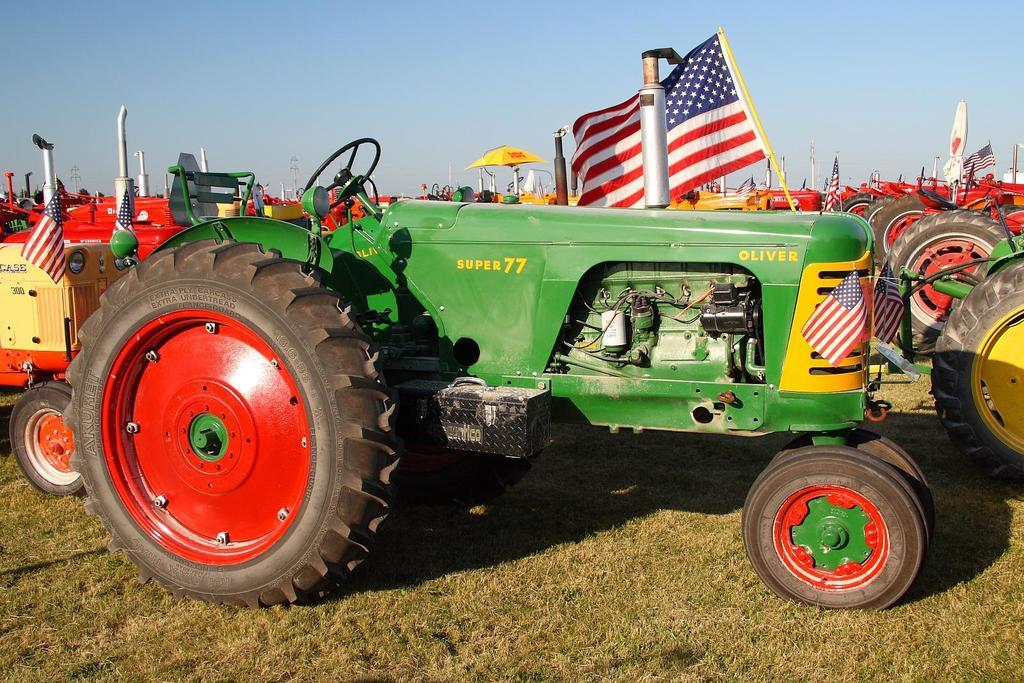What is the main subject of the image? The main subject of the image is a tractor on the grass surface. Are there any other similar objects in the image? Yes, there are other tractors visible behind the first tractor. What can be seen in the background of the image? The sky is visible in the background of the image. Can you tell me what type of dog is sitting next to the tractor in the image? There is no dog present in the image; it features a tractor on the grass surface and other tractors in the background. 